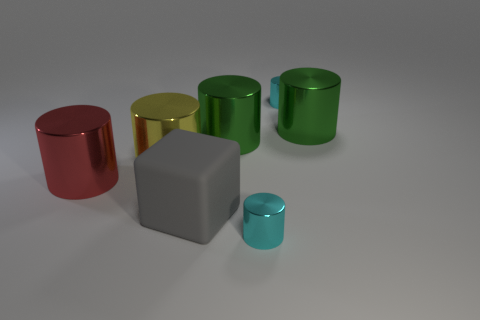Are there any other things that are the same shape as the large gray matte thing?
Offer a very short reply. No. There is a large yellow shiny object; what number of big yellow objects are to the right of it?
Provide a succinct answer. 0. Are there any other things that have the same material as the red thing?
Offer a terse response. Yes. There is a cyan thing in front of the big gray thing; does it have the same shape as the gray object?
Keep it short and to the point. No. There is a big metal cylinder that is in front of the yellow shiny thing; what is its color?
Offer a very short reply. Red. What is the shape of the large red object that is the same material as the yellow cylinder?
Ensure brevity in your answer.  Cylinder. Is there any other thing of the same color as the rubber cube?
Offer a very short reply. No. Are there more large green metallic cylinders that are on the left side of the large gray cube than big gray cubes that are behind the yellow cylinder?
Provide a succinct answer. No. What number of other blocks have the same size as the matte cube?
Ensure brevity in your answer.  0. Are there fewer rubber objects that are behind the red cylinder than gray matte objects in front of the large rubber thing?
Provide a short and direct response. No. 